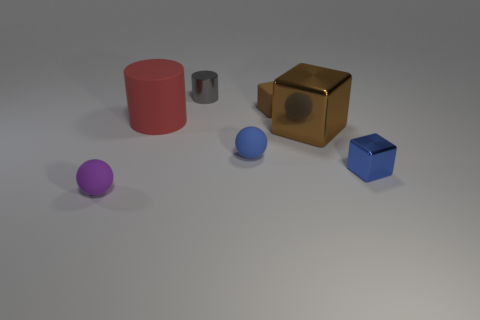Add 2 gray metal things. How many objects exist? 9 Subtract all cylinders. How many objects are left? 5 Add 4 tiny metallic cylinders. How many tiny metallic cylinders are left? 5 Add 6 balls. How many balls exist? 8 Subtract 0 yellow blocks. How many objects are left? 7 Subtract all metal blocks. Subtract all big brown shiny things. How many objects are left? 4 